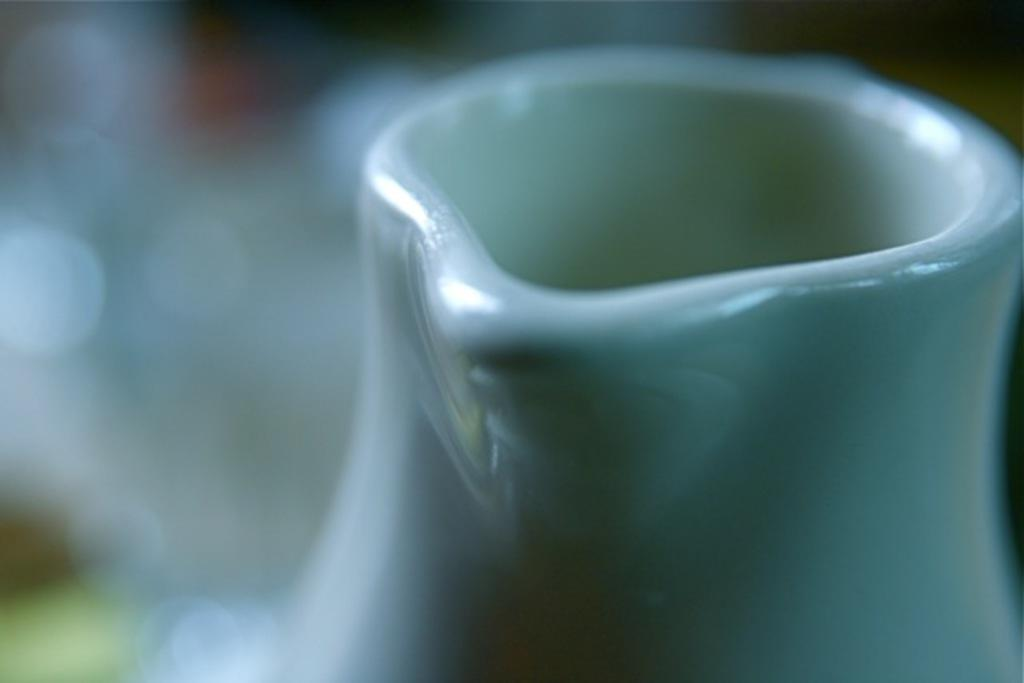What object is the main subject of the image? There is a jug in the image. Can you describe the background of the image? The background of the image is blurred. What type of record is being set in the image? There is no record or competition present in the image; it only features a jug and a blurred background. What is the person in the image doing with their mouth? There is no person present in the image, so it is not possible to determine what they might be doing with their mouth. 